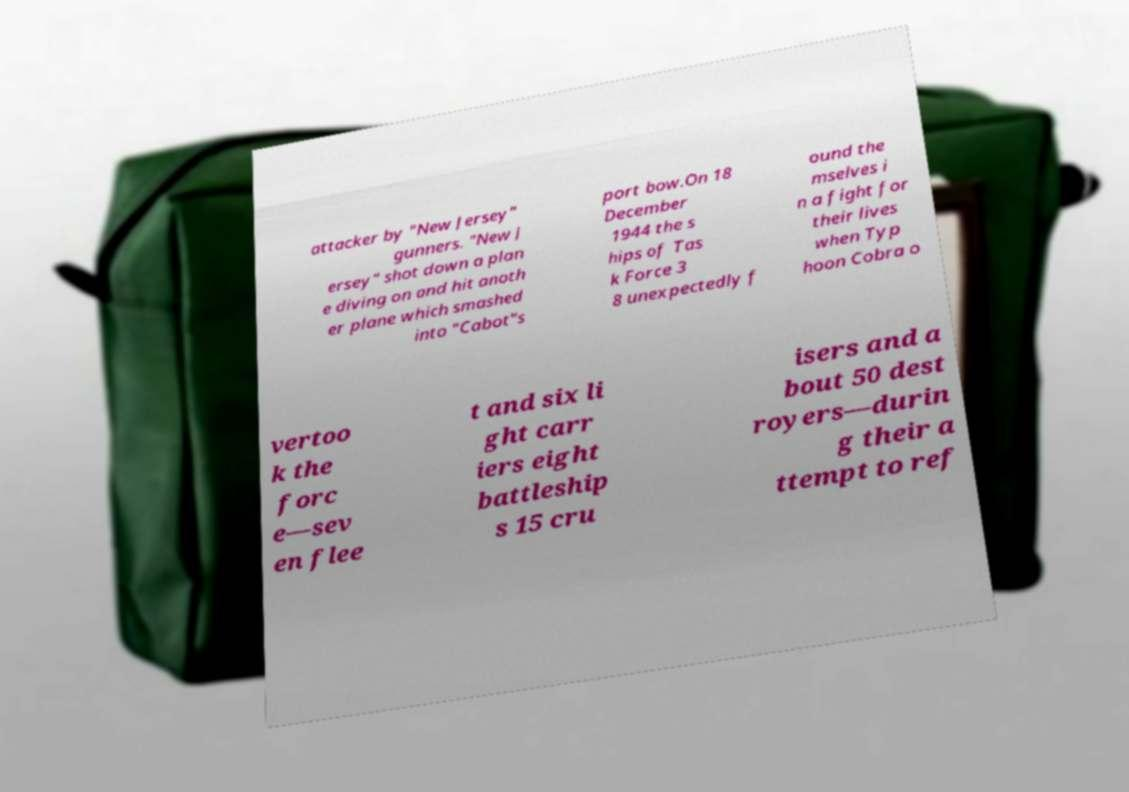Please read and relay the text visible in this image. What does it say? attacker by "New Jersey" gunners. "New J ersey" shot down a plan e diving on and hit anoth er plane which smashed into "Cabot"s port bow.On 18 December 1944 the s hips of Tas k Force 3 8 unexpectedly f ound the mselves i n a fight for their lives when Typ hoon Cobra o vertoo k the forc e—sev en flee t and six li ght carr iers eight battleship s 15 cru isers and a bout 50 dest royers—durin g their a ttempt to ref 